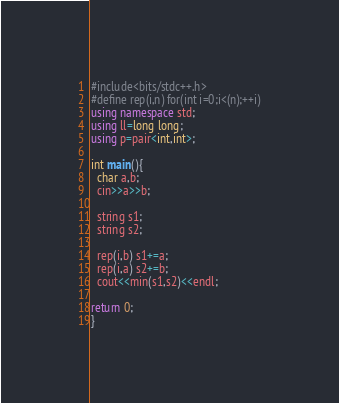<code> <loc_0><loc_0><loc_500><loc_500><_C++_>#include<bits/stdc++.h>
#define rep(i,n) for(int i=0;i<(n);++i)
using namespace std;
using ll=long long;
using p=pair<int,int>;

int main(){
  char a,b;
  cin>>a>>b;
  
  string s1;
  string s2;
  
  rep(i,b) s1+=a;
  rep(i,a) s2+=b;
  cout<<min(s1,s2)<<endl;

return 0;
}
</code> 